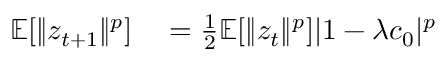<formula> <loc_0><loc_0><loc_500><loc_500>\begin{array} { r l } { \mathbb { E } [ \| z _ { t + 1 } \| ^ { p } ] } & = \frac { 1 } { 2 } \mathbb { E } [ \| z _ { t } \| ^ { p } ] | 1 - \lambda c _ { 0 } | ^ { p } } \end{array}</formula> 